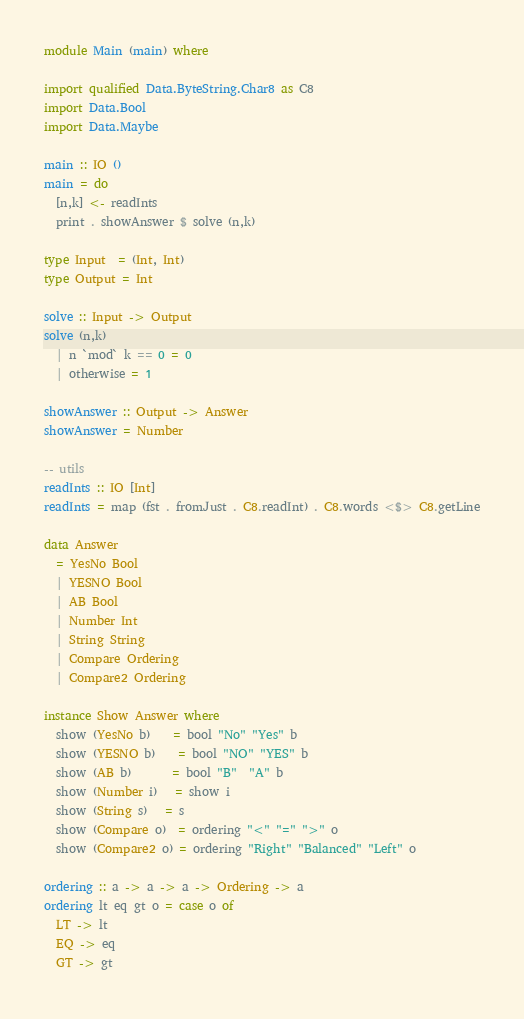Convert code to text. <code><loc_0><loc_0><loc_500><loc_500><_Haskell_>module Main (main) where

import qualified Data.ByteString.Char8 as C8
import Data.Bool
import Data.Maybe

main :: IO ()
main = do
  [n,k] <- readInts
  print . showAnswer $ solve (n,k)

type Input  = (Int, Int)
type Output = Int

solve :: Input -> Output
solve (n,k)
  | n `mod` k == 0 = 0
  | otherwise = 1

showAnswer :: Output -> Answer
showAnswer = Number

-- utils
readInts :: IO [Int]
readInts = map (fst . fromJust . C8.readInt) . C8.words <$> C8.getLine

data Answer
  = YesNo Bool
  | YESNO Bool
  | AB Bool
  | Number Int
  | String String
  | Compare Ordering
  | Compare2 Ordering

instance Show Answer where
  show (YesNo b)    = bool "No" "Yes" b
  show (YESNO b)    = bool "NO" "YES" b
  show (AB b)       = bool "B"  "A" b
  show (Number i)   = show i
  show (String s)   = s
  show (Compare o)  = ordering "<" "=" ">" o
  show (Compare2 o) = ordering "Right" "Balanced" "Left" o

ordering :: a -> a -> a -> Ordering -> a
ordering lt eq gt o = case o of
  LT -> lt
  EQ -> eq
  GT -> gt</code> 